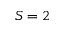Convert formula to latex. <formula><loc_0><loc_0><loc_500><loc_500>S = 2</formula> 